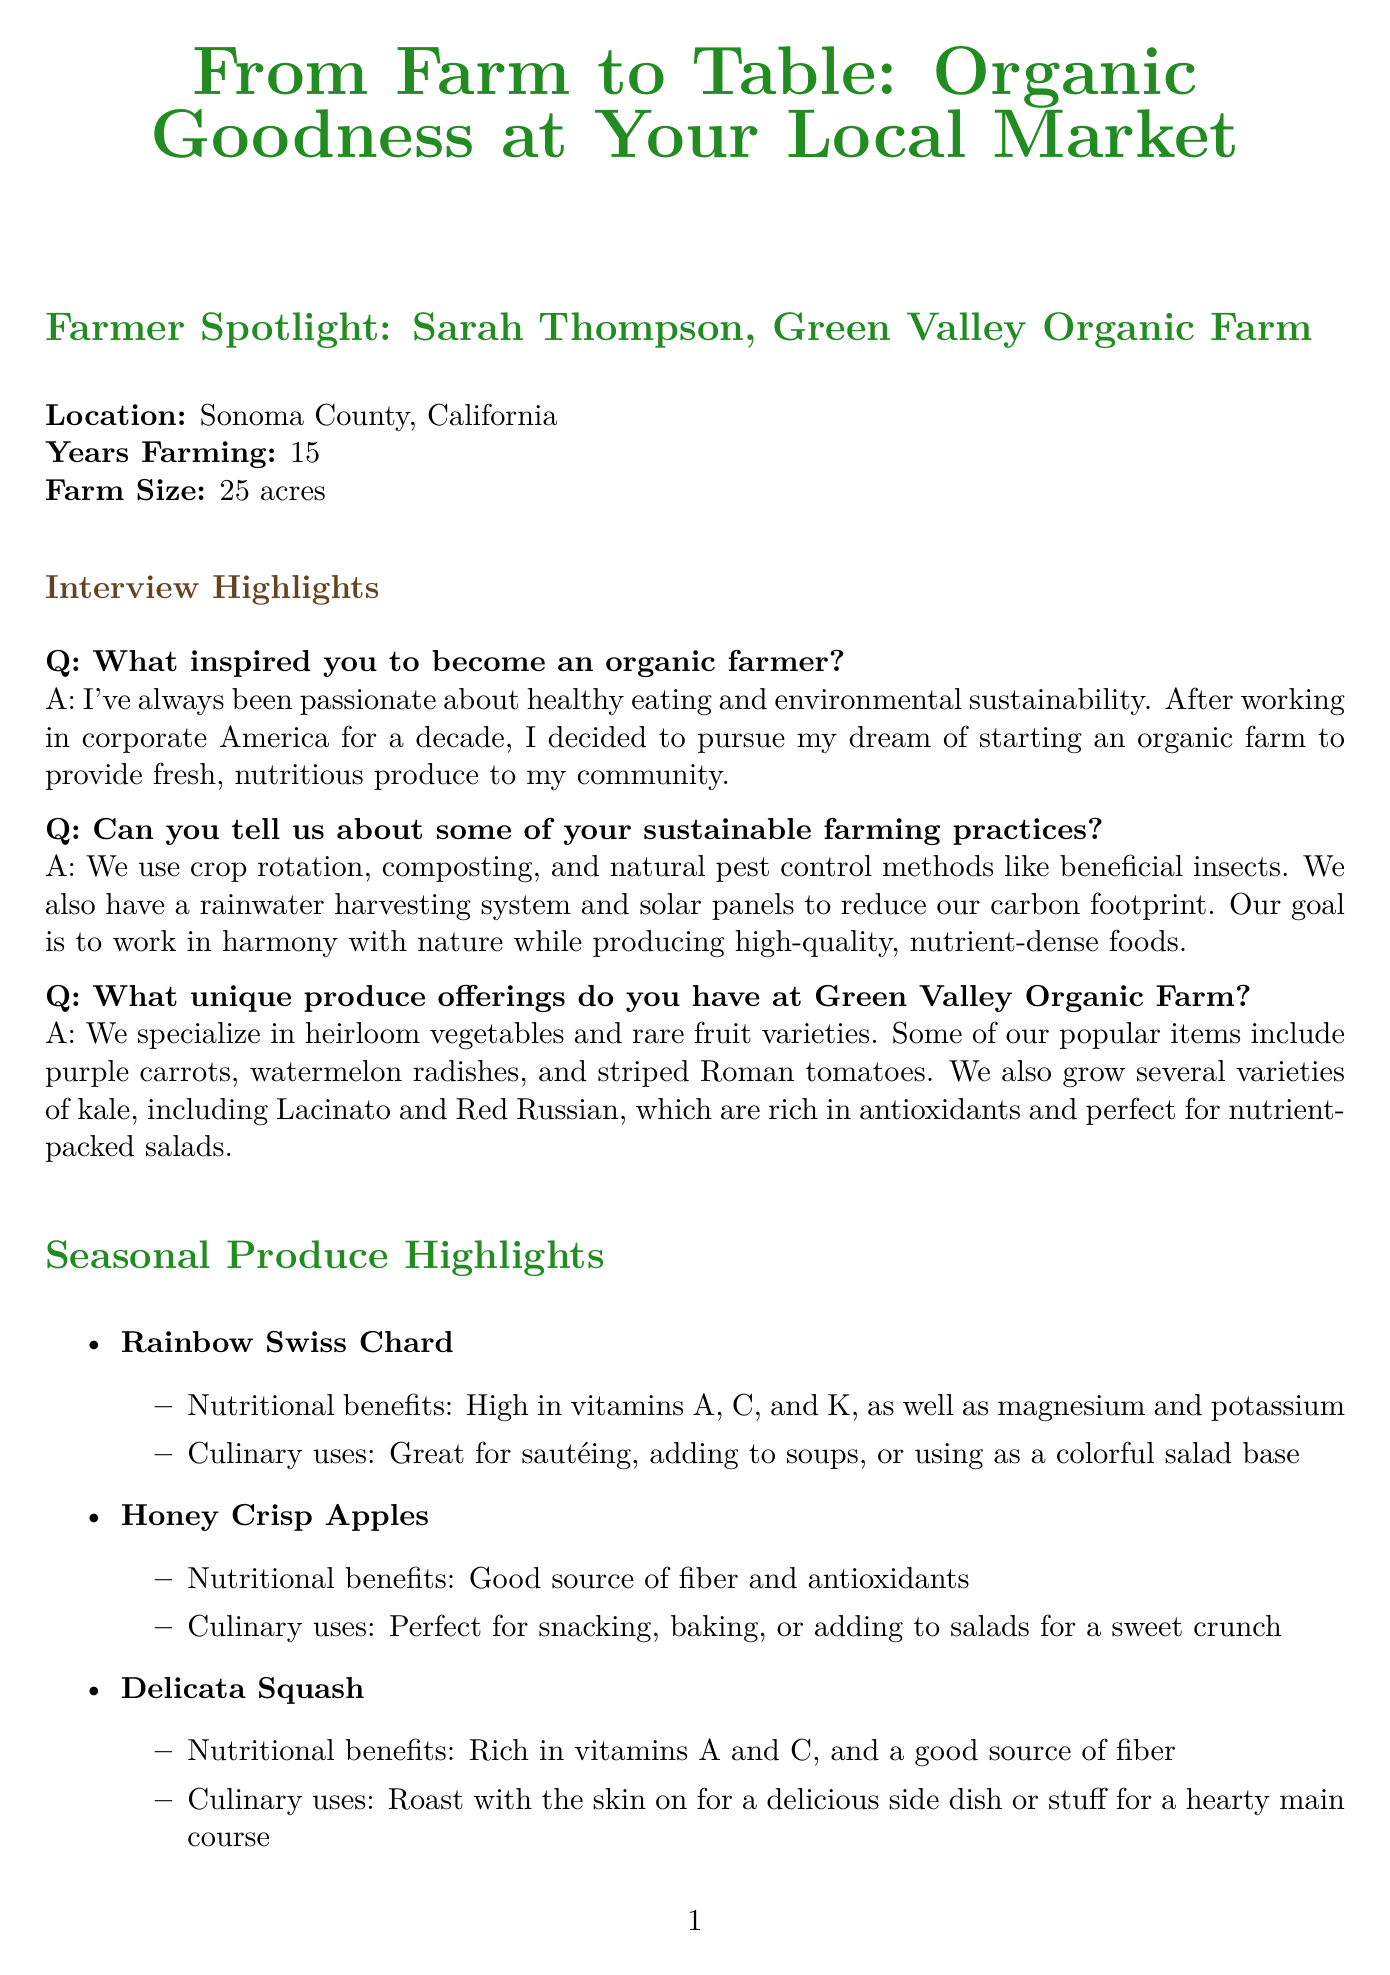What is the name of the farmer? The farmer's name is mentioned in the Farmer Spotlight section.
Answer: Sarah Thompson What is the size of Green Valley Organic Farm? The document states the size of the farm in acres in the Farmer Spotlight section.
Answer: 25 acres What unique produce does the farm specialize in? Unique produce offerings are summarized in the interview highlights.
Answer: Heirloom vegetables and rare fruit varieties How long has Sarah Thompson been farming? This information is found in the Farmer Spotlight under "Years Farming."
Answer: 15 years What is one method used for pest control at the farm? Sustainable farming practices mention various methods, specifically regarding pest control.
Answer: Beneficial insects What are the nutritional benefits of Rainbow Swiss Chard? The nutritional benefits are listed alongside each seasonal produce highlight.
Answer: High in vitamins A, C, and K, as well as magnesium and potassium What time does the farmer's market open on Saturdays? The call to action details the days and times of the market.
Answer: 8 AM What is a culinary use for Delicata Squash? The document lists culinary uses for each seasonal produce item.
Answer: Roast with the skin on What is the title of the recipe spotlighted in the newsletter? The document mentions the recipe title under a specific section.
Answer: Farm-Fresh Rainbow Salad 